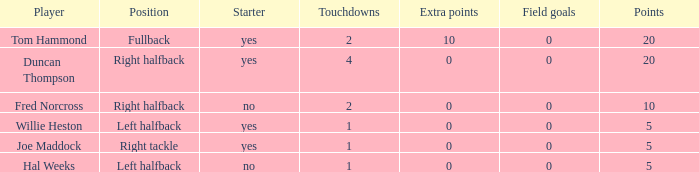What is the lowest number of field goals when the points were less than 5? None. 